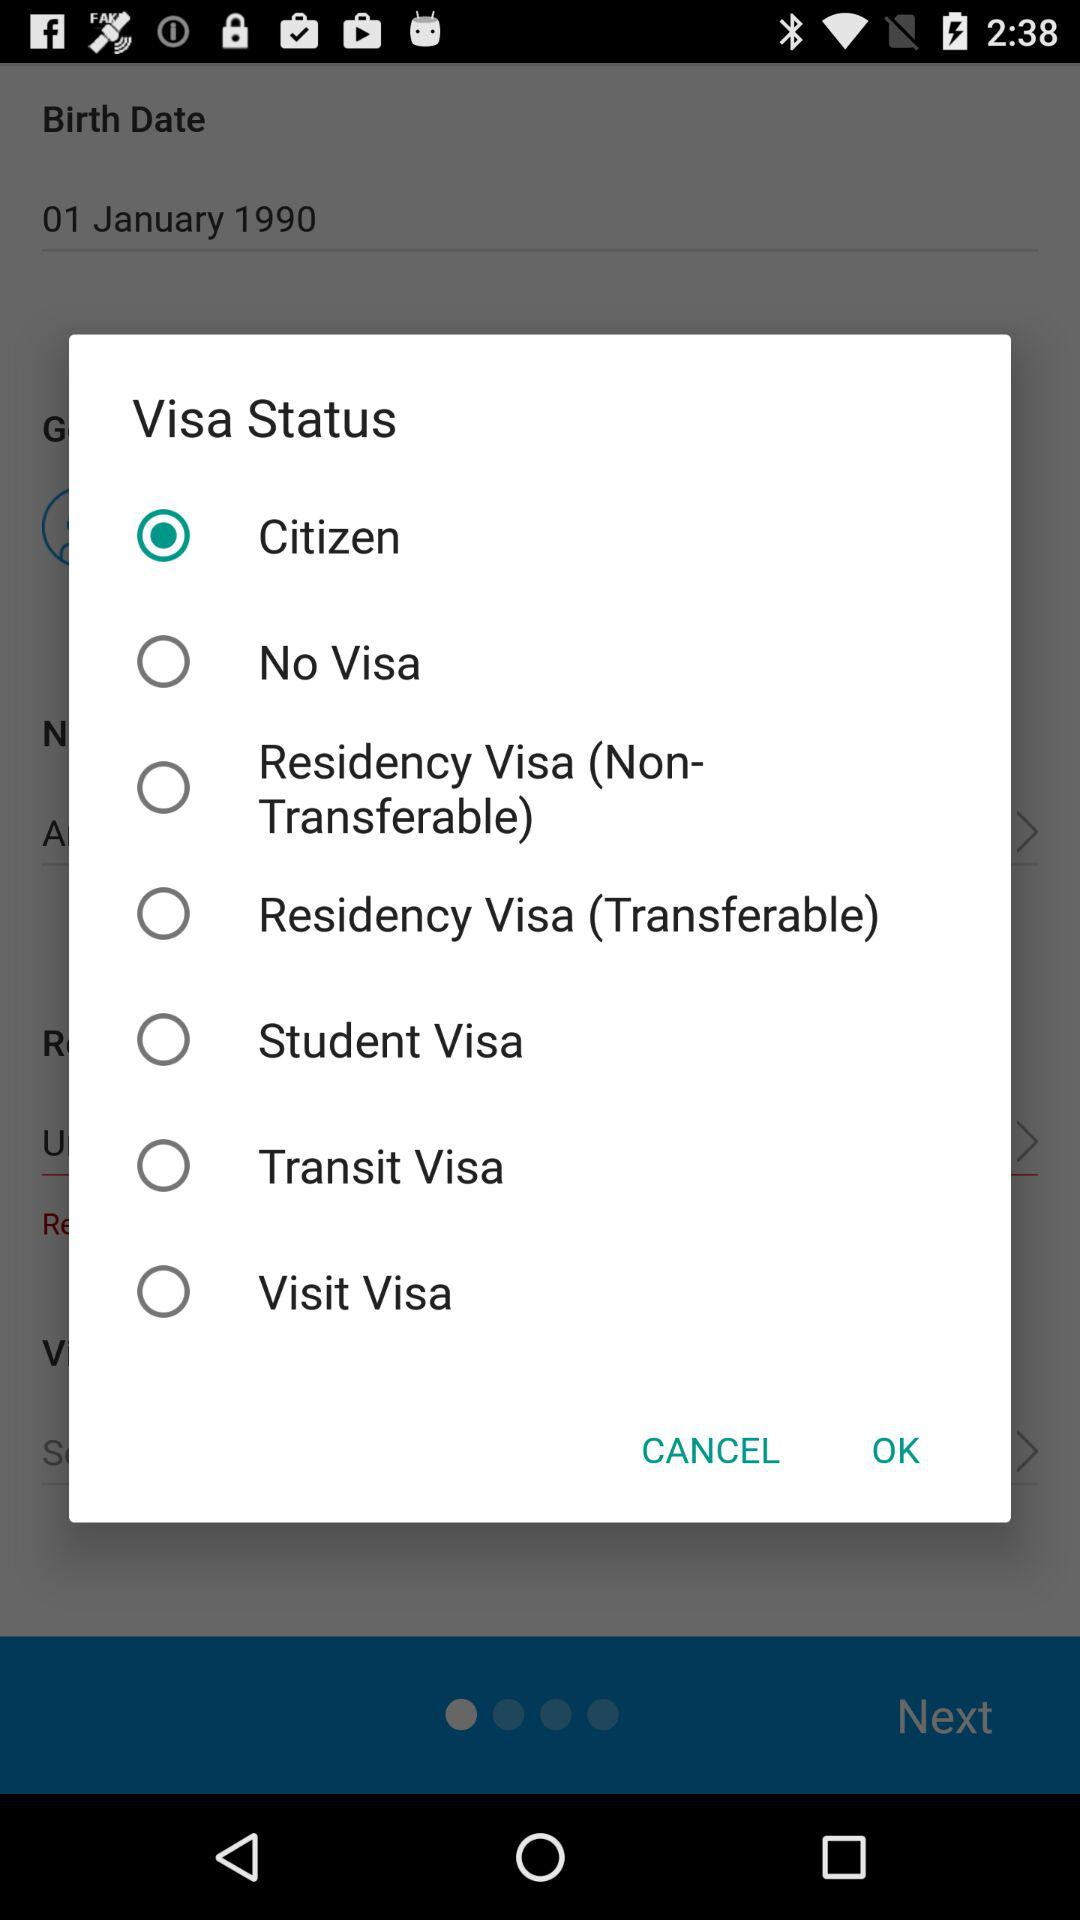What is the status of "No Visa"? The status is "off". 